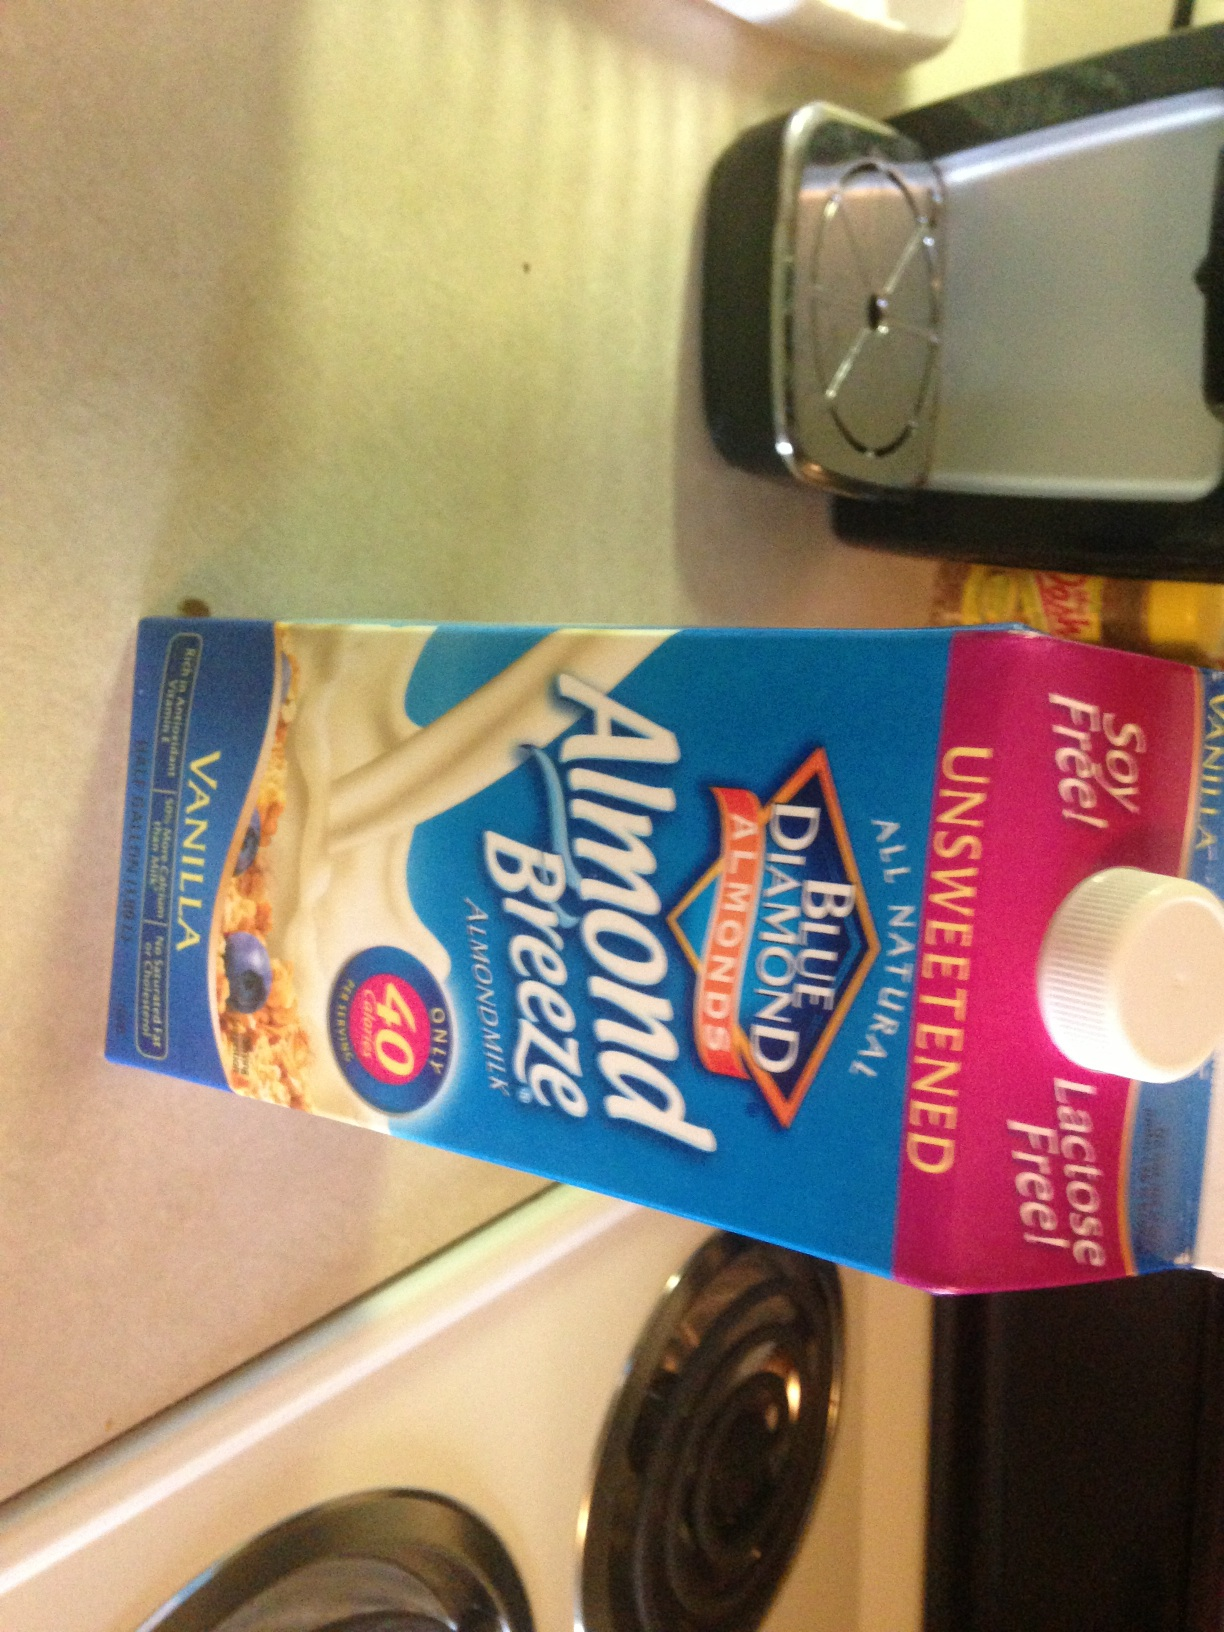Can you tell me more about the nutritional benefits of unsweetened almond milk? Unsweetened almond milk is a low-calorie beverage, containing only about 30 to 50 calories per 8-ounce serving, and has no added sugars. It's a good source of calcium and often fortified with vitamins D and E. It's also dairy-free, making it a suitable option for vegans and those with lactose intolerance. 